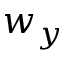<formula> <loc_0><loc_0><loc_500><loc_500>w _ { y }</formula> 